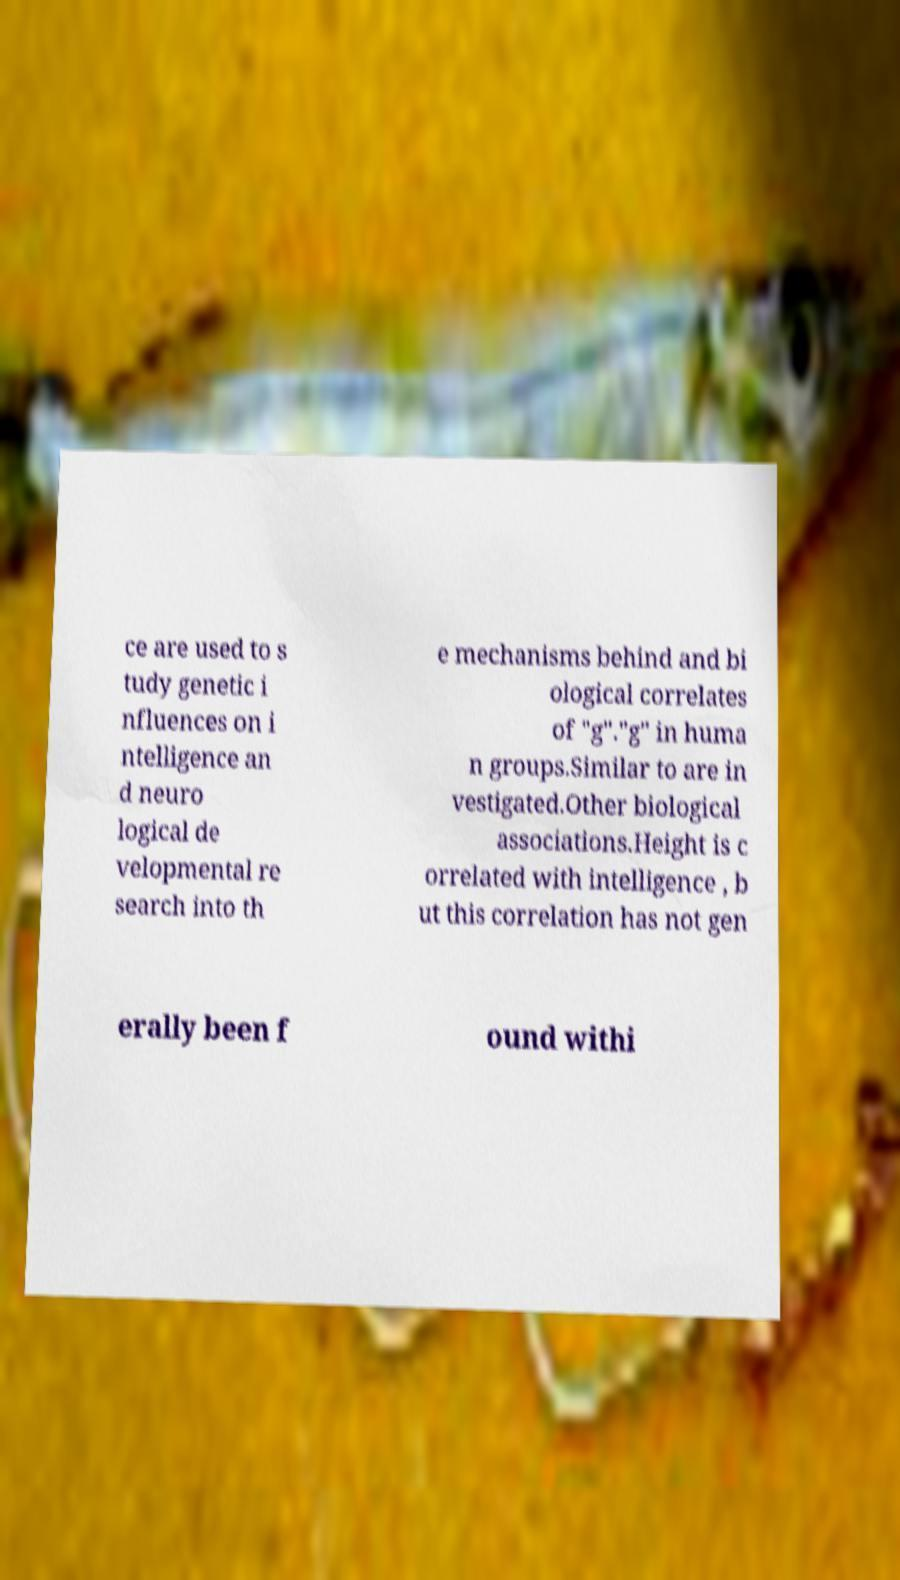There's text embedded in this image that I need extracted. Can you transcribe it verbatim? ce are used to s tudy genetic i nfluences on i ntelligence an d neuro logical de velopmental re search into th e mechanisms behind and bi ological correlates of "g"."g" in huma n groups.Similar to are in vestigated.Other biological associations.Height is c orrelated with intelligence , b ut this correlation has not gen erally been f ound withi 